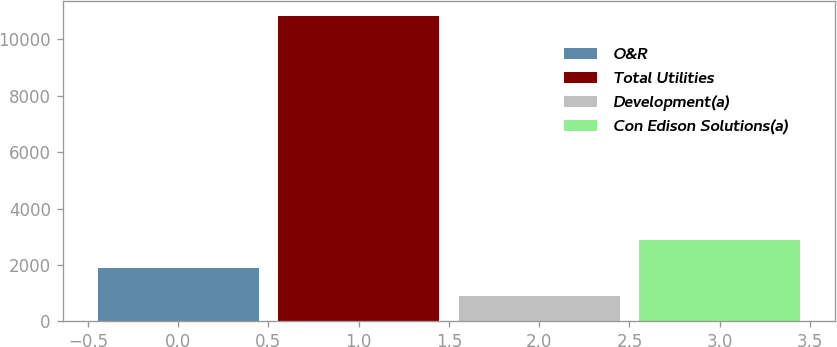Convert chart to OTSL. <chart><loc_0><loc_0><loc_500><loc_500><bar_chart><fcel>O&R<fcel>Total Utilities<fcel>Development(a)<fcel>Con Edison Solutions(a)<nl><fcel>1891.2<fcel>10821<fcel>899<fcel>2883.4<nl></chart> 